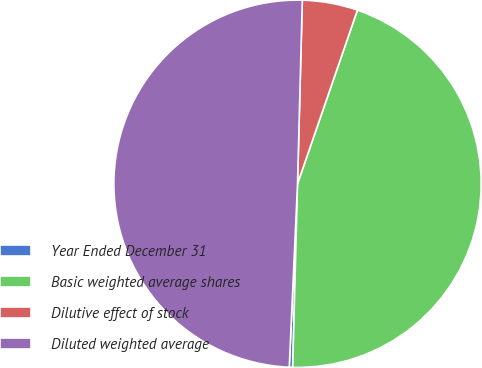Convert chart. <chart><loc_0><loc_0><loc_500><loc_500><pie_chart><fcel>Year Ended December 31<fcel>Basic weighted average shares<fcel>Dilutive effect of stock<fcel>Diluted weighted average<nl><fcel>0.3%<fcel>45.13%<fcel>4.87%<fcel>49.7%<nl></chart> 